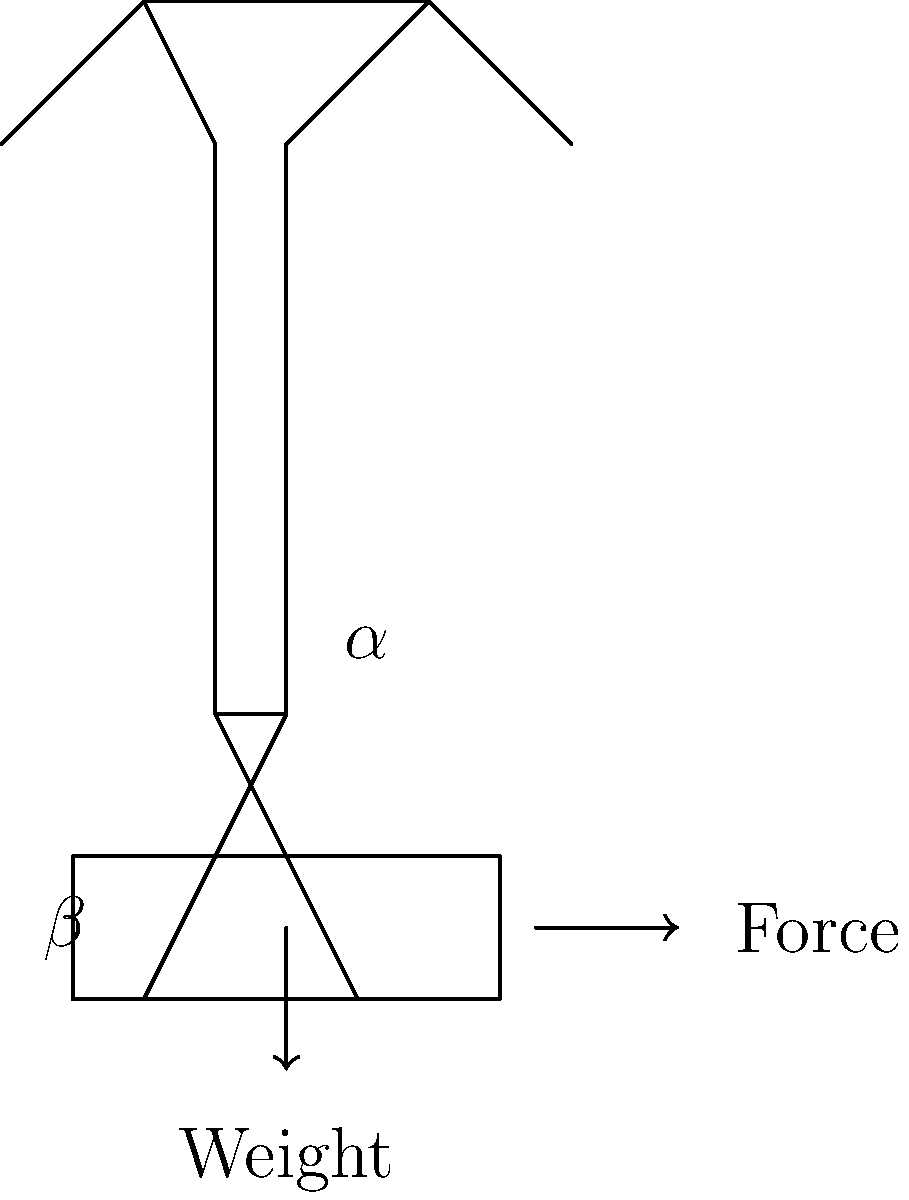As a parent involved in school activities, you're helping to organize a fundraising event that involves moving heavy boxes. To ensure safety, you want to educate volunteers on proper lifting techniques. In the diagram, $\alpha$ represents the angle of the back relative to the vertical, and $\beta$ represents the angle of the thighs relative to the vertical. Which combination of angles ($\alpha$, $\beta$) would result in the most biomechanically efficient and safe lifting posture?

A) ($0°$, $0°$)
B) ($45°$, $0°$)
C) ($0°$, $45°$)
D) ($45°$, $45°$) To determine the most biomechanically efficient and safe lifting posture, let's consider each option:

1. ($0°$, $0°$): This represents a completely upright posture with straight legs. While it keeps the back straight, it puts excessive strain on the lower back and doesn't utilize the leg muscles effectively.

2. ($45°$, $0°$): This posture involves bending the back at a 45° angle while keeping the legs straight. This is a dangerous position that puts significant stress on the lower back and spinal discs.

3. ($0°$, $45°$): This represents a posture where the back is kept straight (vertical) while the knees are bent at a 45° angle. This is the correct posture for safe lifting because:
   a) It maintains the natural curvature of the spine, reducing the risk of back injuries.
   b) It engages the strong leg muscles (quadriceps and glutes) to perform the lift.
   c) It brings the center of gravity of the lifter closer to the object, reducing the moment arm and thus the required force.

4. ($45°$, $45°$): While this posture does engage the leg muscles, the bent back position increases the risk of spinal injuries.

The biomechanically efficient and safe lifting technique, often referred to as the "squat lift," involves:
1. Keeping the back straight and close to vertical ($\alpha = 0°$)
2. Bending at the knees and hips ($\beta \approx 45°$)
3. Holding the object close to the body
4. Lifting with the leg muscles rather than the back muscles

Therefore, the correct answer is C ($0°$, $45°$), as it best represents the proper lifting technique that minimizes the risk of injury and maximizes the use of strong leg muscles.
Answer: C ($0°$, $45°$) 